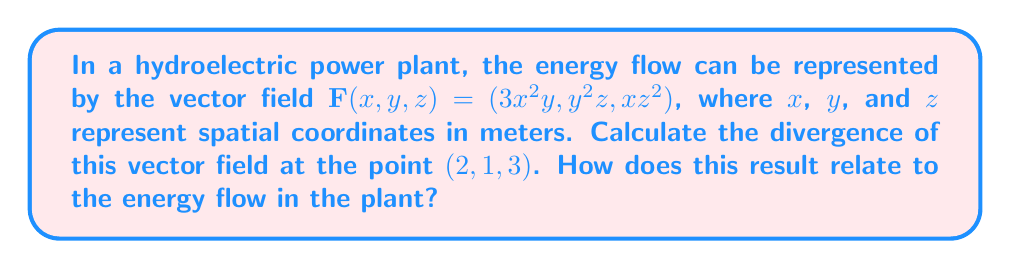Can you solve this math problem? To solve this problem, we'll follow these steps:

1) The divergence of a vector field $\mathbf{F}(x,y,z) = (F_x, F_y, F_z)$ is given by:

   $$\text{div}\mathbf{F} = \nabla \cdot \mathbf{F} = \frac{\partial F_x}{\partial x} + \frac{\partial F_y}{\partial y} + \frac{\partial F_z}{\partial z}$$

2) For our vector field $\mathbf{F}(x,y,z) = (3x^2y, y^2z, xz^2)$, we need to calculate:

   $$\frac{\partial F_x}{\partial x} = \frac{\partial (3x^2y)}{\partial x} = 6xy$$
   
   $$\frac{\partial F_y}{\partial y} = \frac{\partial (y^2z)}{\partial y} = 2yz$$
   
   $$\frac{\partial F_z}{\partial z} = \frac{\partial (xz^2)}{\partial z} = 2xz$$

3) The divergence is the sum of these partial derivatives:

   $$\text{div}\mathbf{F} = 6xy + 2yz + 2xz$$

4) To find the divergence at the point $(2,1,3)$, we substitute these values:

   $$\text{div}\mathbf{F}(2,1,3) = 6(2)(1) + 2(1)(3) + 2(2)(3) = 12 + 6 + 12 = 30$$

5) In the context of a hydroelectric power plant, a positive divergence at this point indicates that there's a net outflow of energy from this location. This could represent a region where energy is being generated or distributed, such as near a turbine or in a power distribution area.
Answer: $30$ m²/s 